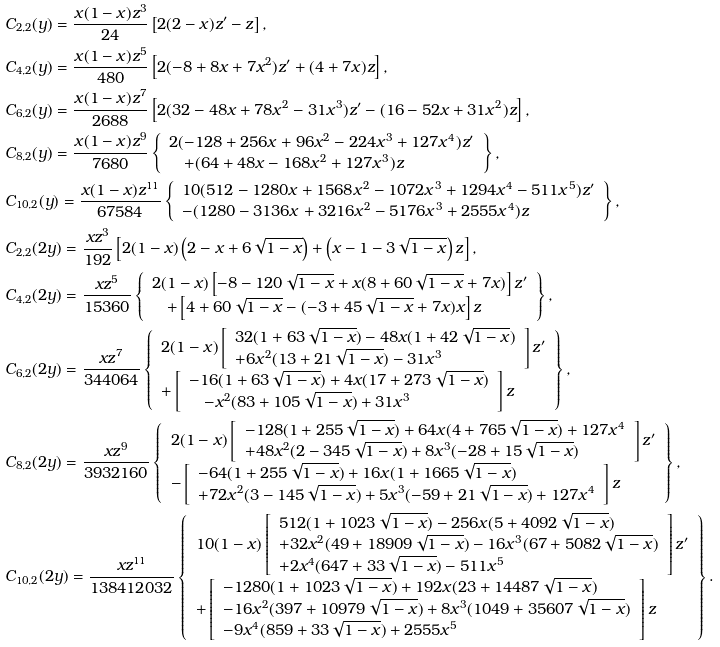Convert formula to latex. <formula><loc_0><loc_0><loc_500><loc_500>& C _ { 2 , 2 } ( y ) = \frac { x ( 1 - x ) z ^ { 3 } } { 2 4 } \left [ 2 ( 2 - x ) z ^ { \prime } - z \right ] , \\ & C _ { 4 , 2 } ( y ) = \frac { x ( 1 - x ) z ^ { 5 } } { 4 8 0 } \left [ 2 ( - 8 + 8 x + 7 x ^ { 2 } ) z ^ { \prime } + ( 4 + 7 x ) z \right ] , \\ & C _ { 6 , 2 } ( y ) = \frac { x ( 1 - x ) z ^ { 7 } } { 2 6 8 8 } \left [ 2 ( 3 2 - 4 8 x + 7 8 x ^ { 2 } - 3 1 x ^ { 3 } ) z ^ { \prime } - ( 1 6 - 5 2 x + 3 1 x ^ { 2 } ) z \right ] , \\ & C _ { 8 , 2 } ( y ) = \frac { x ( 1 - x ) z ^ { 9 } } { 7 6 8 0 } \left \{ \begin{array} { l } 2 ( - 1 2 8 + 2 5 6 x + 9 6 x ^ { 2 } - 2 2 4 x ^ { 3 } + 1 2 7 x ^ { 4 } ) z ^ { \prime } \\ \quad + ( 6 4 + 4 8 x - 1 6 8 x ^ { 2 } + 1 2 7 x ^ { 3 } ) z \end{array} \right \} , \\ & C _ { 1 0 , 2 } ( y ) = \frac { x ( 1 - x ) z ^ { 1 1 } } { 6 7 5 8 4 } \left \{ \begin{array} { l } 1 0 ( 5 1 2 - 1 2 8 0 x + 1 5 6 8 x ^ { 2 } - 1 0 7 2 x ^ { 3 } + 1 2 9 4 x ^ { 4 } - 5 1 1 x ^ { 5 } ) z ^ { \prime } \\ - ( 1 2 8 0 - 3 1 3 6 x + 3 2 1 6 x ^ { 2 } - 5 1 7 6 x ^ { 3 } + 2 5 5 5 x ^ { 4 } ) z \end{array} \right \} , \\ & C _ { 2 , 2 } ( 2 y ) = \frac { x z ^ { 3 } } { 1 9 2 } \left [ 2 ( 1 - x ) \left ( 2 - x + 6 \sqrt { 1 - x } \right ) + \left ( x - 1 - 3 \sqrt { 1 - x } \right ) z \right ] , \\ & C _ { 4 , 2 } ( 2 y ) = \frac { x z ^ { 5 } } { 1 5 3 6 0 } \left \{ \begin{array} { l } 2 ( 1 - x ) \left [ - 8 - 1 2 0 \sqrt { 1 - x } + x ( 8 + 6 0 \sqrt { 1 - x } + 7 x ) \right ] z ^ { \prime } \\ \quad + \left [ 4 + 6 0 \sqrt { 1 - x } - ( - 3 + 4 5 \sqrt { 1 - x } + 7 x ) x \right ] z \end{array} \right \} , \\ & C _ { 6 , 2 } ( 2 y ) = \frac { x z ^ { 7 } } { 3 4 4 0 6 4 } \left \{ \begin{array} { l } 2 ( 1 - x ) \left [ \begin{array} { l } 3 2 ( 1 + 6 3 \sqrt { 1 - x } ) - 4 8 x ( 1 + 4 2 \sqrt { 1 - x } ) \\ + 6 x ^ { 2 } ( 1 3 + 2 1 \sqrt { 1 - x } ) - 3 1 x ^ { 3 } \end{array} \right ] z ^ { \prime } \\ + \left [ \begin{array} { l } - 1 6 ( 1 + 6 3 \sqrt { 1 - x } ) + 4 x ( 1 7 + 2 7 3 \sqrt { 1 - x } ) \\ \quad - x ^ { 2 } ( 8 3 + 1 0 5 \sqrt { 1 - x } ) + 3 1 x ^ { 3 } \end{array} \right ] z \end{array} \right \} , \\ & C _ { 8 , 2 } ( 2 y ) = \frac { x z ^ { 9 } } { 3 9 3 2 1 6 0 } \left \{ \begin{array} { l } 2 ( 1 - x ) \left [ \begin{array} { l } - 1 2 8 ( 1 + 2 5 5 \sqrt { 1 - x } ) + 6 4 x ( 4 + 7 6 5 \sqrt { 1 - x } ) + 1 2 7 x ^ { 4 } \\ + 4 8 x ^ { 2 } ( 2 - 3 4 5 \sqrt { 1 - x } ) + 8 x ^ { 3 } ( - 2 8 + 1 5 \sqrt { 1 - x } ) \end{array} \right ] z ^ { \prime } \\ - \left [ \begin{array} { l } - 6 4 ( 1 + 2 5 5 \sqrt { 1 - x } ) + 1 6 x ( 1 + 1 6 6 5 \sqrt { 1 - x } ) \\ + 7 2 x ^ { 2 } ( 3 - 1 4 5 \sqrt { 1 - x } ) + 5 x ^ { 3 } ( - 5 9 + 2 1 \sqrt { 1 - x } ) + 1 2 7 x ^ { 4 } \end{array} \right ] z \end{array} \right \} , \\ & C _ { 1 0 , 2 } ( 2 y ) = \frac { x z ^ { 1 1 } } { 1 3 8 4 1 2 0 3 2 } \left \{ \begin{array} { l } 1 0 ( 1 - x ) \left [ \begin{array} { l } 5 1 2 ( 1 + 1 0 2 3 \sqrt { 1 - x } ) - 2 5 6 x ( 5 + 4 0 9 2 \sqrt { 1 - x } ) \\ + 3 2 x ^ { 2 } ( 4 9 + 1 8 9 0 9 \sqrt { 1 - x } ) - 1 6 x ^ { 3 } ( 6 7 + 5 0 8 2 \sqrt { 1 - x } ) \\ + 2 x ^ { 4 } ( 6 4 7 + 3 3 \sqrt { 1 - x } ) - 5 1 1 x ^ { 5 } \end{array} \right ] z ^ { \prime } \\ + \left [ \begin{array} { l } - 1 2 8 0 ( 1 + 1 0 2 3 \sqrt { 1 - x } ) + 1 9 2 x ( 2 3 + 1 4 4 8 7 \sqrt { 1 - x } ) \\ - 1 6 x ^ { 2 } ( 3 9 7 + 1 0 9 7 9 \sqrt { 1 - x } ) + 8 x ^ { 3 } ( 1 0 4 9 + 3 5 6 0 7 \sqrt { 1 - x } ) \\ - 9 x ^ { 4 } ( 8 5 9 + 3 3 \sqrt { 1 - x } ) + 2 5 5 5 x ^ { 5 } \end{array} \right ] z \end{array} \right \} .</formula> 